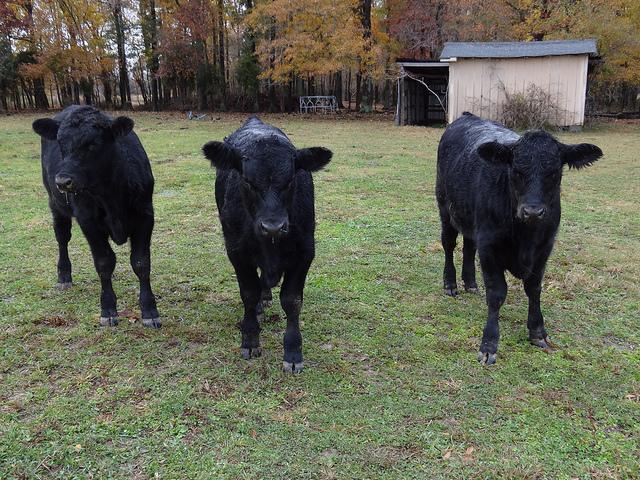How many cows are facing the camera?
Short answer required. 3. How many adult cows are in the picture?
Keep it brief. 3. How many cows are on the grass?
Give a very brief answer. 3. What are the cows doing?
Keep it brief. Standing. 